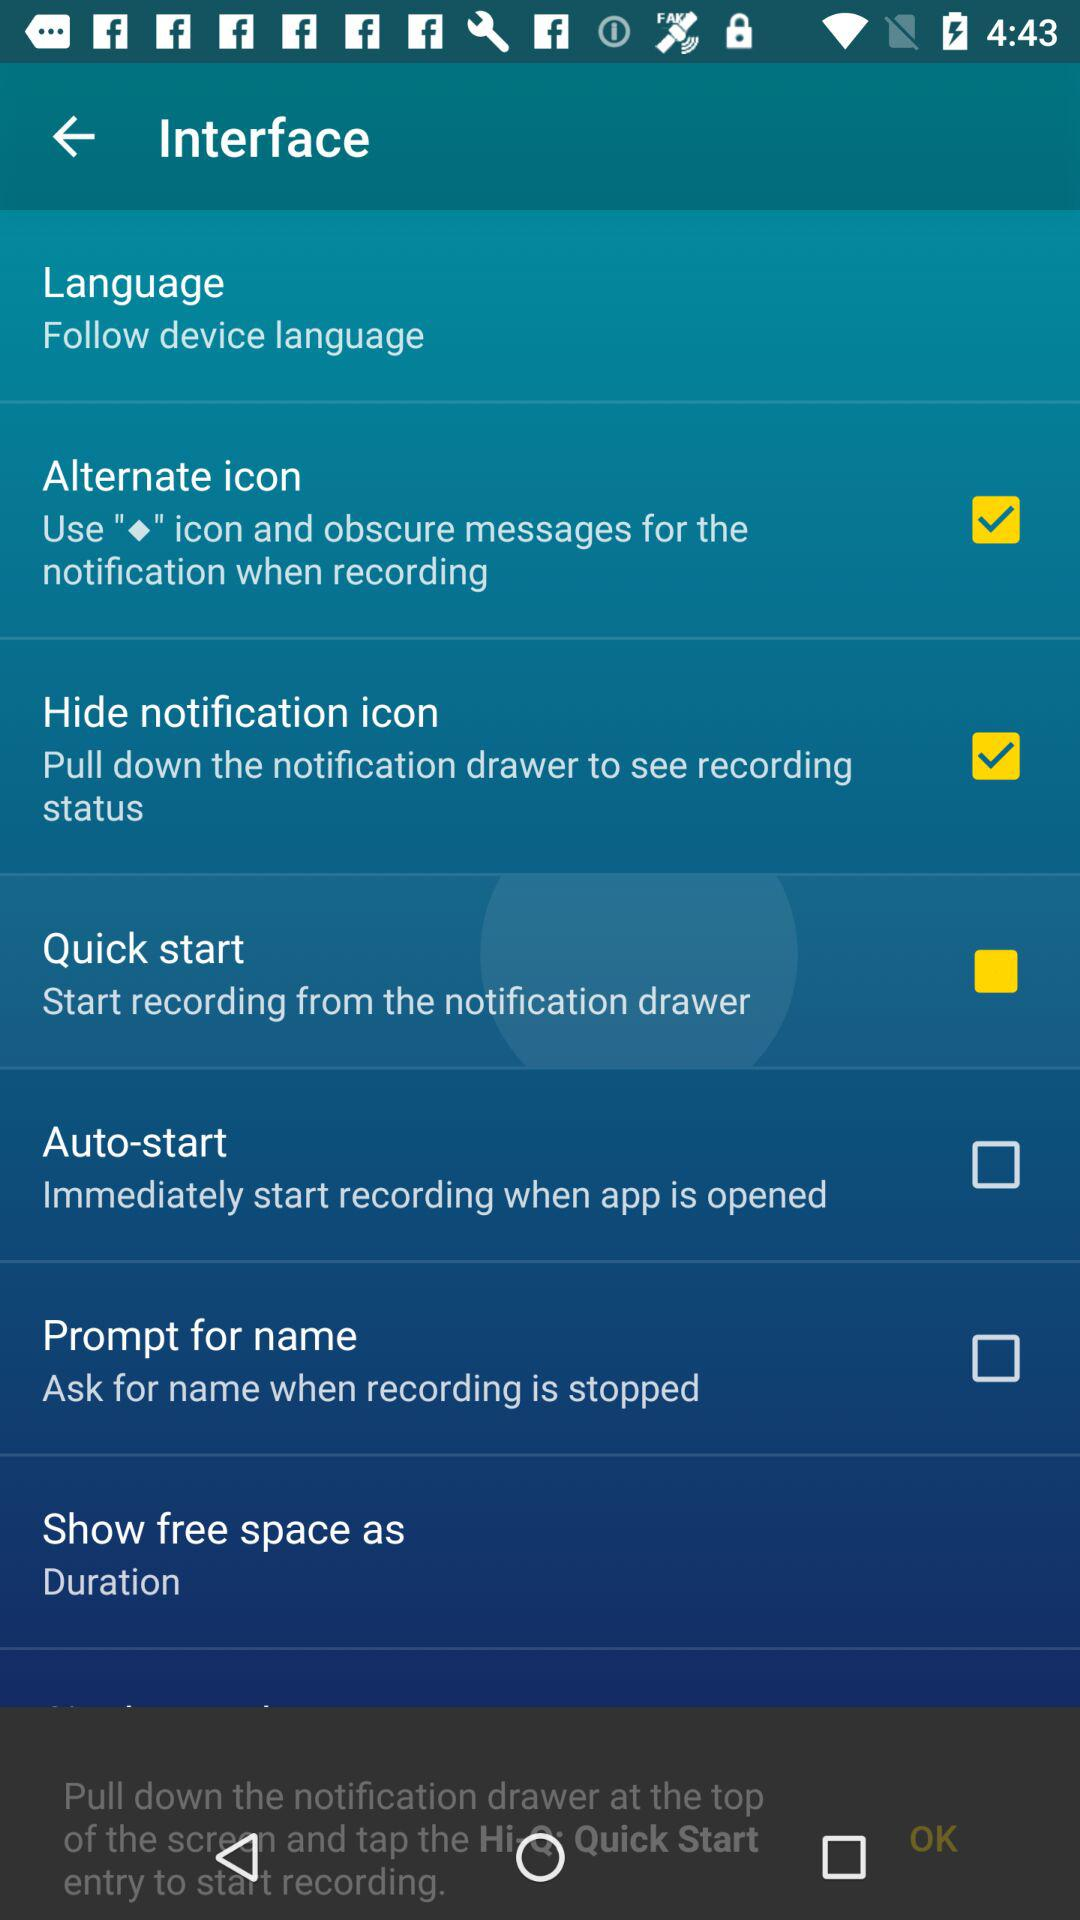What is the status of the "Hide notification icon"? The status of the "Hide notification icon" is "on". 